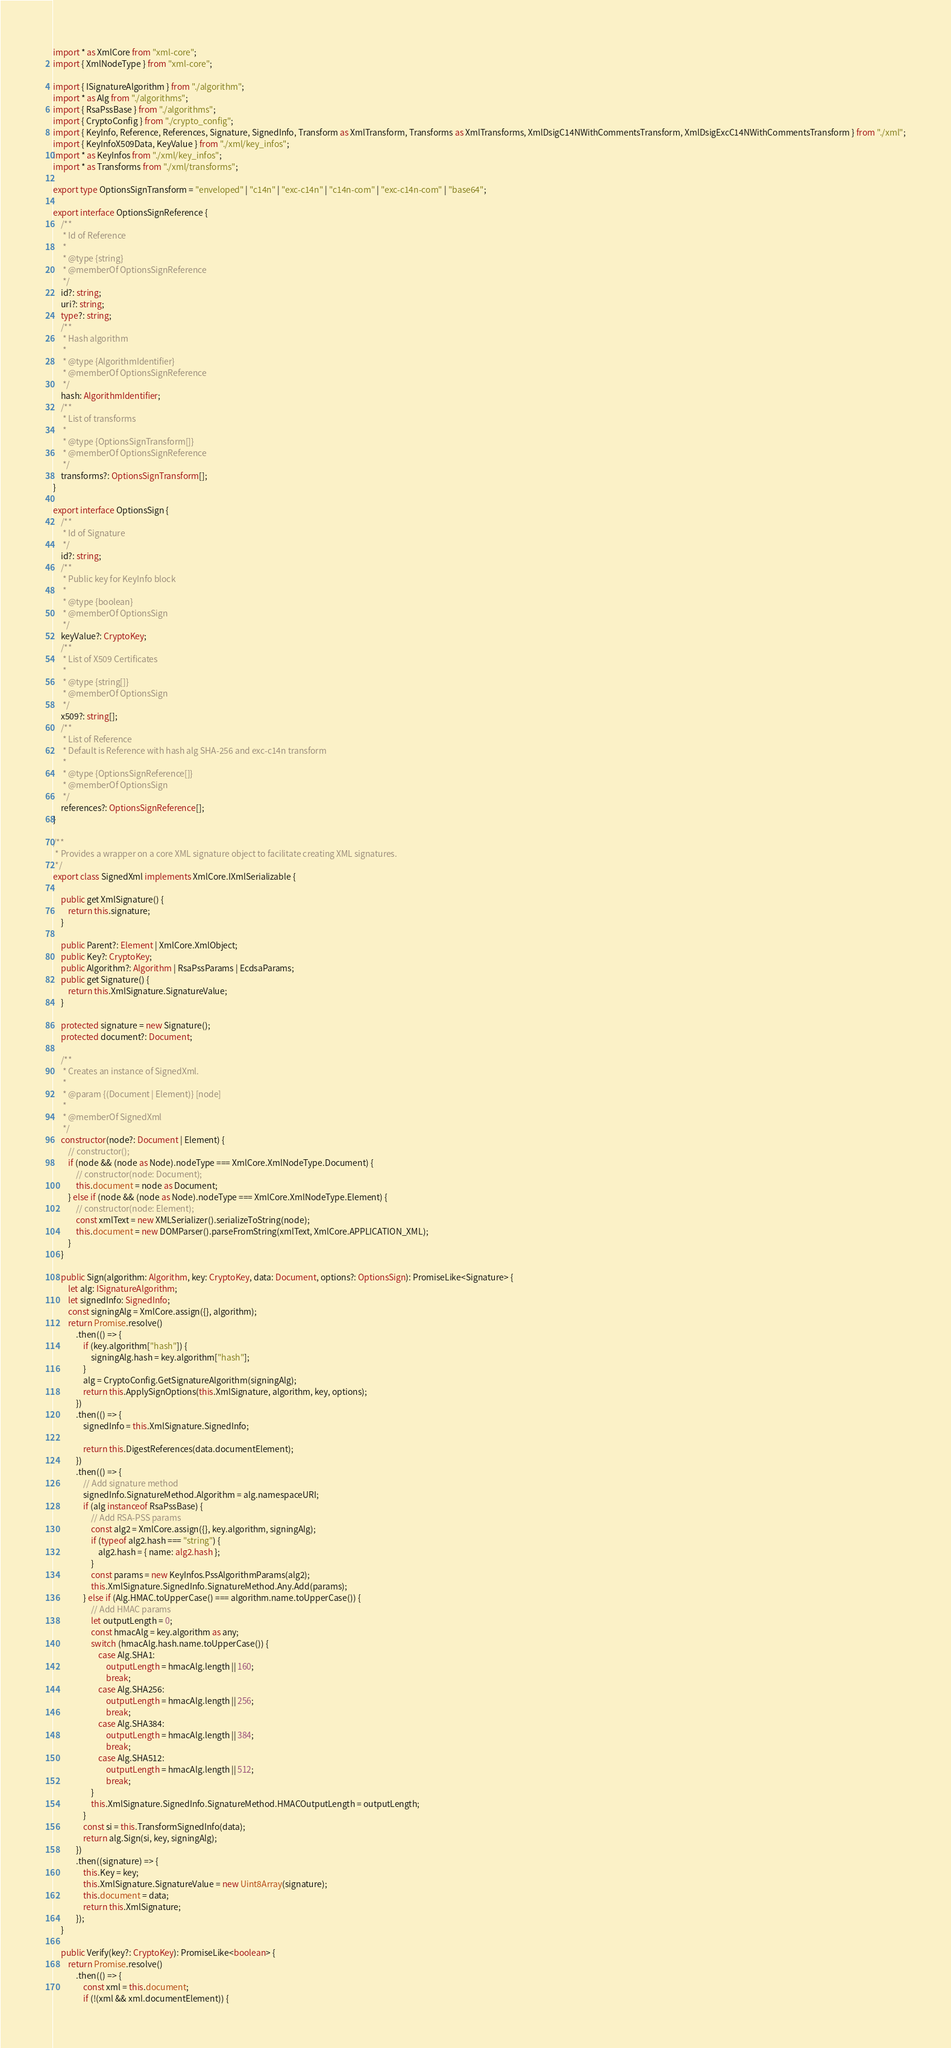Convert code to text. <code><loc_0><loc_0><loc_500><loc_500><_TypeScript_>import * as XmlCore from "xml-core";
import { XmlNodeType } from "xml-core";

import { ISignatureAlgorithm } from "./algorithm";
import * as Alg from "./algorithms";
import { RsaPssBase } from "./algorithms";
import { CryptoConfig } from "./crypto_config";
import { KeyInfo, Reference, References, Signature, SignedInfo, Transform as XmlTransform, Transforms as XmlTransforms, XmlDsigC14NWithCommentsTransform, XmlDsigExcC14NWithCommentsTransform } from "./xml";
import { KeyInfoX509Data, KeyValue } from "./xml/key_infos";
import * as KeyInfos from "./xml/key_infos";
import * as Transforms from "./xml/transforms";

export type OptionsSignTransform = "enveloped" | "c14n" | "exc-c14n" | "c14n-com" | "exc-c14n-com" | "base64";

export interface OptionsSignReference {
    /**
     * Id of Reference
     *
     * @type {string}
     * @memberOf OptionsSignReference
     */
    id?: string;
    uri?: string;
    type?: string;
    /**
     * Hash algorithm
     *
     * @type {AlgorithmIdentifier}
     * @memberOf OptionsSignReference
     */
    hash: AlgorithmIdentifier;
    /**
     * List of transforms
     *
     * @type {OptionsSignTransform[]}
     * @memberOf OptionsSignReference
     */
    transforms?: OptionsSignTransform[];
}

export interface OptionsSign {
    /**
     * Id of Signature
     */
    id?: string;
    /**
     * Public key for KeyInfo block
     *
     * @type {boolean}
     * @memberOf OptionsSign
     */
    keyValue?: CryptoKey;
    /**
     * List of X509 Certificates
     *
     * @type {string[]}
     * @memberOf OptionsSign
     */
    x509?: string[];
    /**
     * List of Reference
     * Default is Reference with hash alg SHA-256 and exc-c14n transform
     *
     * @type {OptionsSignReference[]}
     * @memberOf OptionsSign
     */
    references?: OptionsSignReference[];
}

/**
 * Provides a wrapper on a core XML signature object to facilitate creating XML signatures.
 */
export class SignedXml implements XmlCore.IXmlSerializable {

    public get XmlSignature() {
        return this.signature;
    }

    public Parent?: Element | XmlCore.XmlObject;
    public Key?: CryptoKey;
    public Algorithm?: Algorithm | RsaPssParams | EcdsaParams;
    public get Signature() {
        return this.XmlSignature.SignatureValue;
    }

    protected signature = new Signature();
    protected document?: Document;

    /**
     * Creates an instance of SignedXml.
     *
     * @param {(Document | Element)} [node]
     *
     * @memberOf SignedXml
     */
    constructor(node?: Document | Element) {
        // constructor();
        if (node && (node as Node).nodeType === XmlCore.XmlNodeType.Document) {
            // constructor(node: Document);
            this.document = node as Document;
        } else if (node && (node as Node).nodeType === XmlCore.XmlNodeType.Element) {
            // constructor(node: Element);
            const xmlText = new XMLSerializer().serializeToString(node);
            this.document = new DOMParser().parseFromString(xmlText, XmlCore.APPLICATION_XML);
        }
    }

    public Sign(algorithm: Algorithm, key: CryptoKey, data: Document, options?: OptionsSign): PromiseLike<Signature> {
        let alg: ISignatureAlgorithm;
        let signedInfo: SignedInfo;
        const signingAlg = XmlCore.assign({}, algorithm);
        return Promise.resolve()
            .then(() => {
                if (key.algorithm["hash"]) {
                    signingAlg.hash = key.algorithm["hash"];
                }
                alg = CryptoConfig.GetSignatureAlgorithm(signingAlg);
                return this.ApplySignOptions(this.XmlSignature, algorithm, key, options);
            })
            .then(() => {
                signedInfo = this.XmlSignature.SignedInfo;

                return this.DigestReferences(data.documentElement);
            })
            .then(() => {
                // Add signature method
                signedInfo.SignatureMethod.Algorithm = alg.namespaceURI;
                if (alg instanceof RsaPssBase) {
                    // Add RSA-PSS params
                    const alg2 = XmlCore.assign({}, key.algorithm, signingAlg);
                    if (typeof alg2.hash === "string") {
                        alg2.hash = { name: alg2.hash };
                    }
                    const params = new KeyInfos.PssAlgorithmParams(alg2);
                    this.XmlSignature.SignedInfo.SignatureMethod.Any.Add(params);
                } else if (Alg.HMAC.toUpperCase() === algorithm.name.toUpperCase()) {
                    // Add HMAC params
                    let outputLength = 0;
                    const hmacAlg = key.algorithm as any;
                    switch (hmacAlg.hash.name.toUpperCase()) {
                        case Alg.SHA1:
                            outputLength = hmacAlg.length || 160;
                            break;
                        case Alg.SHA256:
                            outputLength = hmacAlg.length || 256;
                            break;
                        case Alg.SHA384:
                            outputLength = hmacAlg.length || 384;
                            break;
                        case Alg.SHA512:
                            outputLength = hmacAlg.length || 512;
                            break;
                    }
                    this.XmlSignature.SignedInfo.SignatureMethod.HMACOutputLength = outputLength;
                }
                const si = this.TransformSignedInfo(data);
                return alg.Sign(si, key, signingAlg);
            })
            .then((signature) => {
                this.Key = key;
                this.XmlSignature.SignatureValue = new Uint8Array(signature);
                this.document = data;
                return this.XmlSignature;
            });
    }

    public Verify(key?: CryptoKey): PromiseLike<boolean> {
        return Promise.resolve()
            .then(() => {
                const xml = this.document;
                if (!(xml && xml.documentElement)) {</code> 